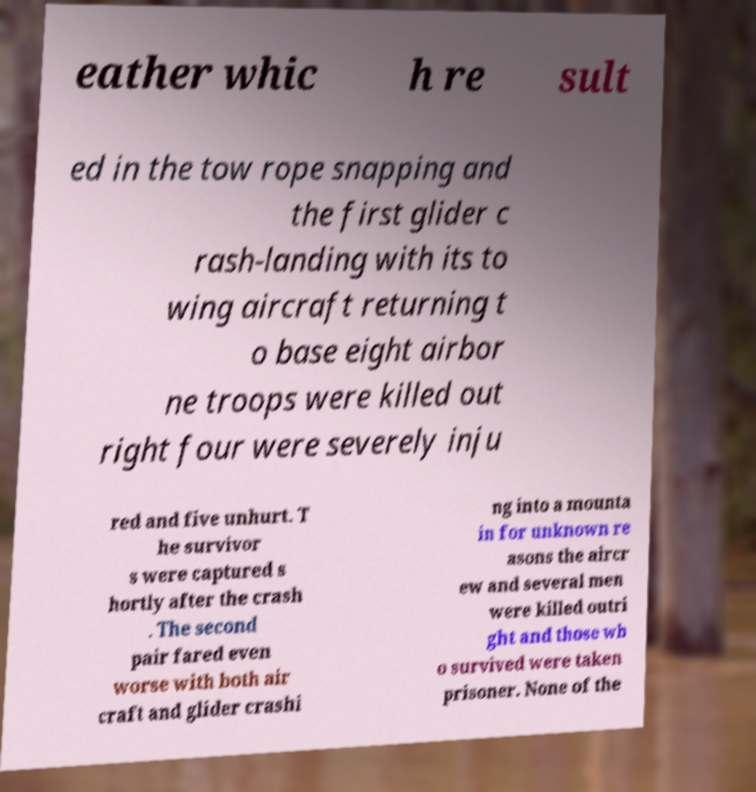Please identify and transcribe the text found in this image. eather whic h re sult ed in the tow rope snapping and the first glider c rash-landing with its to wing aircraft returning t o base eight airbor ne troops were killed out right four were severely inju red and five unhurt. T he survivor s were captured s hortly after the crash . The second pair fared even worse with both air craft and glider crashi ng into a mounta in for unknown re asons the aircr ew and several men were killed outri ght and those wh o survived were taken prisoner. None of the 